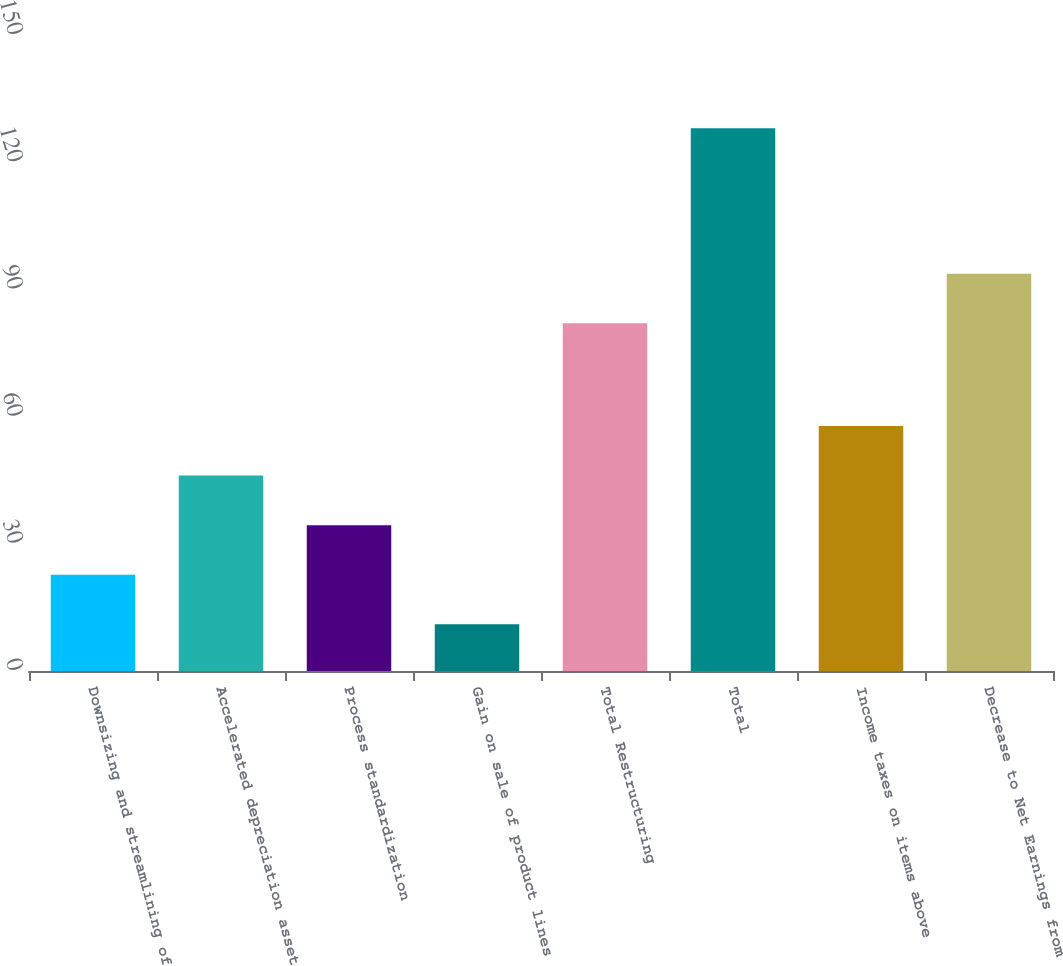Convert chart. <chart><loc_0><loc_0><loc_500><loc_500><bar_chart><fcel>Downsizing and streamlining of<fcel>Accelerated depreciation asset<fcel>Process standardization<fcel>Gain on sale of product lines<fcel>Total Restructuring<fcel>Total<fcel>Income taxes on items above<fcel>Decrease to Net Earnings from<nl><fcel>22.7<fcel>46.1<fcel>34.4<fcel>11<fcel>82<fcel>128<fcel>57.8<fcel>93.7<nl></chart> 